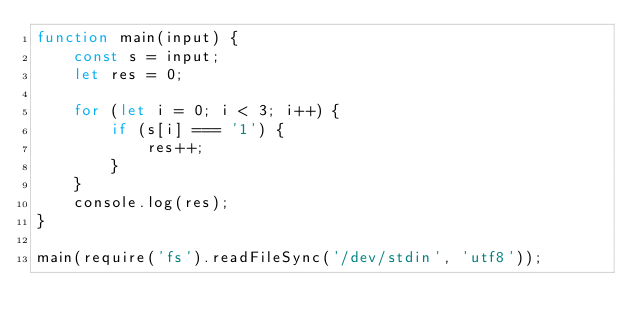Convert code to text. <code><loc_0><loc_0><loc_500><loc_500><_JavaScript_>function main(input) {
    const s = input;
    let res = 0;

    for (let i = 0; i < 3; i++) {
        if (s[i] === '1') {
            res++;
        }
    }
    console.log(res);
}

main(require('fs').readFileSync('/dev/stdin', 'utf8'));</code> 